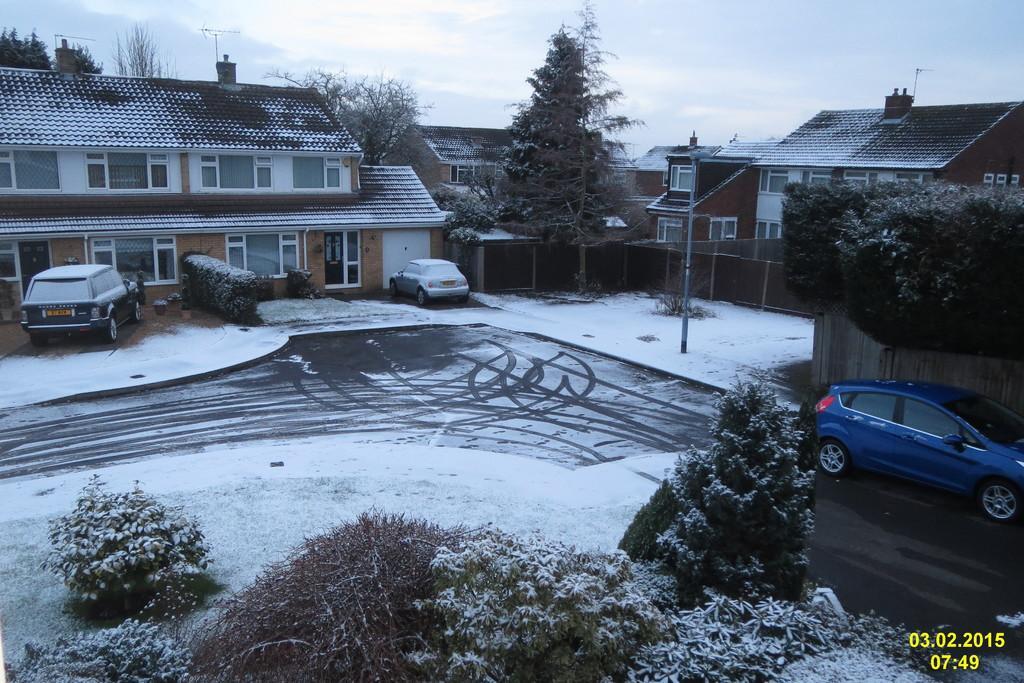How would you summarize this image in a sentence or two? In this picture we can see there are two cars parked. In front of the cars, there are houses, an antenna and the sky. Behind the cars, there is a pole. On the right side of the image, there is another car on the road. At the bottom of the image, there are trees and snow. 